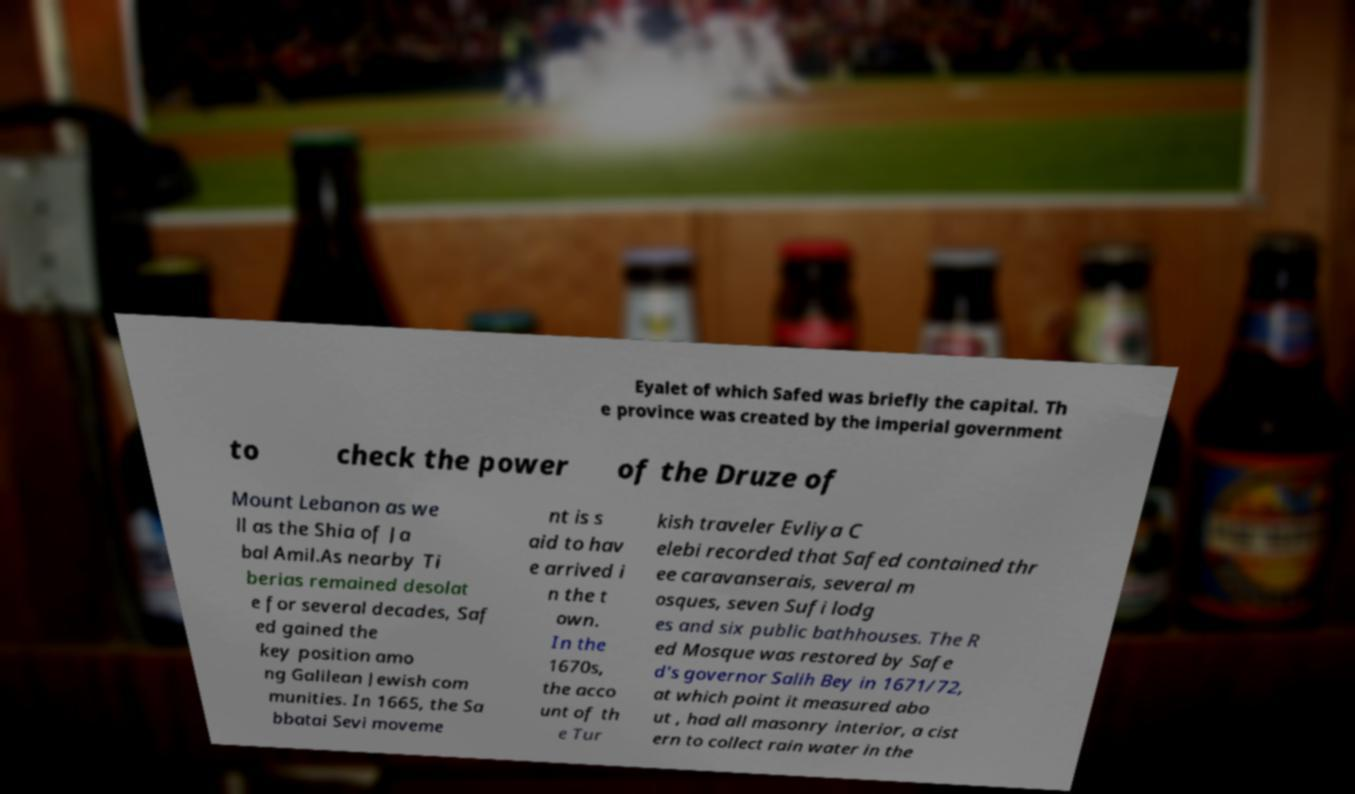I need the written content from this picture converted into text. Can you do that? Eyalet of which Safed was briefly the capital. Th e province was created by the imperial government to check the power of the Druze of Mount Lebanon as we ll as the Shia of Ja bal Amil.As nearby Ti berias remained desolat e for several decades, Saf ed gained the key position amo ng Galilean Jewish com munities. In 1665, the Sa bbatai Sevi moveme nt is s aid to hav e arrived i n the t own. In the 1670s, the acco unt of th e Tur kish traveler Evliya C elebi recorded that Safed contained thr ee caravanserais, several m osques, seven Sufi lodg es and six public bathhouses. The R ed Mosque was restored by Safe d's governor Salih Bey in 1671/72, at which point it measured abo ut , had all masonry interior, a cist ern to collect rain water in the 